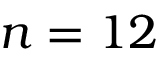Convert formula to latex. <formula><loc_0><loc_0><loc_500><loc_500>n = 1 2</formula> 